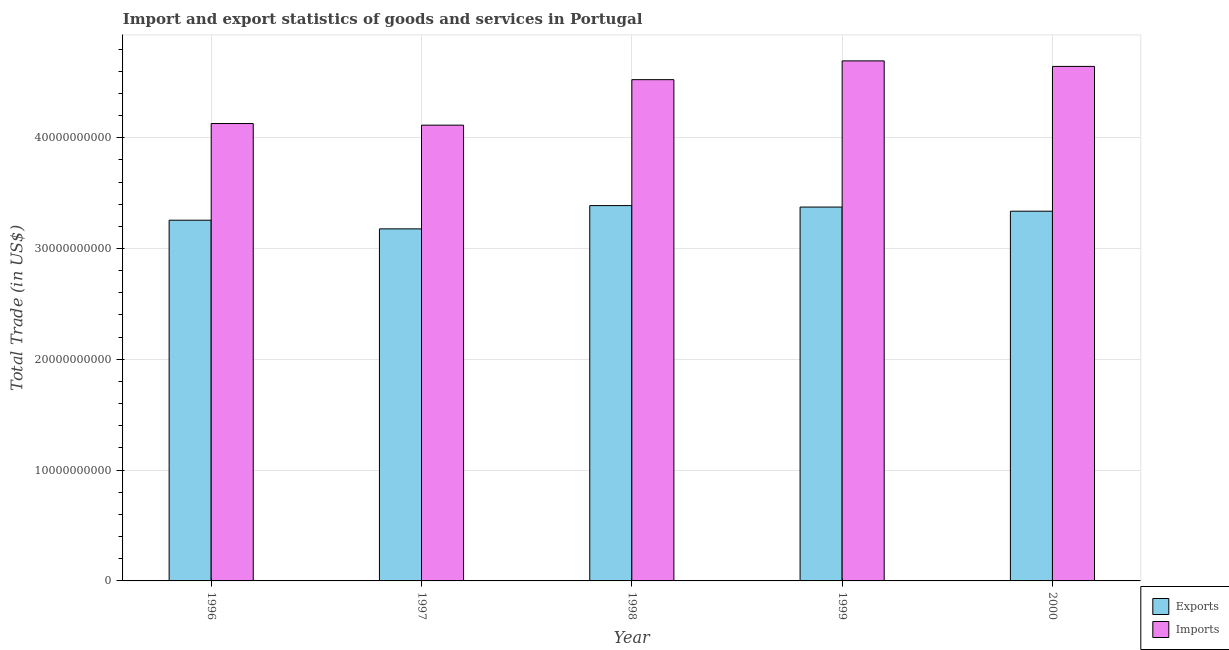How many different coloured bars are there?
Make the answer very short. 2. How many groups of bars are there?
Keep it short and to the point. 5. Are the number of bars on each tick of the X-axis equal?
Your answer should be very brief. Yes. How many bars are there on the 4th tick from the left?
Your answer should be compact. 2. How many bars are there on the 4th tick from the right?
Your answer should be compact. 2. In how many cases, is the number of bars for a given year not equal to the number of legend labels?
Your answer should be very brief. 0. What is the imports of goods and services in 1999?
Make the answer very short. 4.69e+1. Across all years, what is the maximum export of goods and services?
Provide a short and direct response. 3.39e+1. Across all years, what is the minimum imports of goods and services?
Offer a terse response. 4.11e+1. In which year was the export of goods and services maximum?
Ensure brevity in your answer.  1998. What is the total export of goods and services in the graph?
Your answer should be very brief. 1.65e+11. What is the difference between the export of goods and services in 1998 and that in 1999?
Give a very brief answer. 1.32e+08. What is the difference between the export of goods and services in 1998 and the imports of goods and services in 1999?
Provide a short and direct response. 1.32e+08. What is the average export of goods and services per year?
Provide a succinct answer. 3.31e+1. In the year 1998, what is the difference between the export of goods and services and imports of goods and services?
Your answer should be compact. 0. What is the ratio of the imports of goods and services in 1996 to that in 1999?
Provide a succinct answer. 0.88. Is the export of goods and services in 1998 less than that in 1999?
Provide a succinct answer. No. Is the difference between the imports of goods and services in 1996 and 2000 greater than the difference between the export of goods and services in 1996 and 2000?
Keep it short and to the point. No. What is the difference between the highest and the second highest export of goods and services?
Give a very brief answer. 1.32e+08. What is the difference between the highest and the lowest imports of goods and services?
Make the answer very short. 5.80e+09. What does the 1st bar from the left in 1997 represents?
Offer a terse response. Exports. What does the 1st bar from the right in 1998 represents?
Your answer should be compact. Imports. Are all the bars in the graph horizontal?
Make the answer very short. No. What is the difference between two consecutive major ticks on the Y-axis?
Your response must be concise. 1.00e+1. Are the values on the major ticks of Y-axis written in scientific E-notation?
Make the answer very short. No. Does the graph contain any zero values?
Offer a terse response. No. Where does the legend appear in the graph?
Make the answer very short. Bottom right. How many legend labels are there?
Your response must be concise. 2. What is the title of the graph?
Make the answer very short. Import and export statistics of goods and services in Portugal. What is the label or title of the Y-axis?
Give a very brief answer. Total Trade (in US$). What is the Total Trade (in US$) of Exports in 1996?
Your response must be concise. 3.26e+1. What is the Total Trade (in US$) in Imports in 1996?
Ensure brevity in your answer.  4.13e+1. What is the Total Trade (in US$) in Exports in 1997?
Provide a succinct answer. 3.18e+1. What is the Total Trade (in US$) in Imports in 1997?
Your answer should be very brief. 4.11e+1. What is the Total Trade (in US$) in Exports in 1998?
Keep it short and to the point. 3.39e+1. What is the Total Trade (in US$) of Imports in 1998?
Provide a short and direct response. 4.52e+1. What is the Total Trade (in US$) of Exports in 1999?
Provide a short and direct response. 3.37e+1. What is the Total Trade (in US$) of Imports in 1999?
Keep it short and to the point. 4.69e+1. What is the Total Trade (in US$) in Exports in 2000?
Your response must be concise. 3.34e+1. What is the Total Trade (in US$) of Imports in 2000?
Offer a terse response. 4.64e+1. Across all years, what is the maximum Total Trade (in US$) in Exports?
Provide a short and direct response. 3.39e+1. Across all years, what is the maximum Total Trade (in US$) in Imports?
Ensure brevity in your answer.  4.69e+1. Across all years, what is the minimum Total Trade (in US$) in Exports?
Your answer should be compact. 3.18e+1. Across all years, what is the minimum Total Trade (in US$) in Imports?
Your response must be concise. 4.11e+1. What is the total Total Trade (in US$) of Exports in the graph?
Offer a very short reply. 1.65e+11. What is the total Total Trade (in US$) in Imports in the graph?
Your answer should be compact. 2.21e+11. What is the difference between the Total Trade (in US$) in Exports in 1996 and that in 1997?
Provide a short and direct response. 7.82e+08. What is the difference between the Total Trade (in US$) of Imports in 1996 and that in 1997?
Your answer should be compact. 1.47e+08. What is the difference between the Total Trade (in US$) in Exports in 1996 and that in 1998?
Your answer should be compact. -1.32e+09. What is the difference between the Total Trade (in US$) of Imports in 1996 and that in 1998?
Offer a terse response. -3.96e+09. What is the difference between the Total Trade (in US$) of Exports in 1996 and that in 1999?
Provide a succinct answer. -1.19e+09. What is the difference between the Total Trade (in US$) in Imports in 1996 and that in 1999?
Offer a very short reply. -5.66e+09. What is the difference between the Total Trade (in US$) of Exports in 1996 and that in 2000?
Keep it short and to the point. -8.12e+08. What is the difference between the Total Trade (in US$) in Imports in 1996 and that in 2000?
Provide a short and direct response. -5.16e+09. What is the difference between the Total Trade (in US$) of Exports in 1997 and that in 1998?
Make the answer very short. -2.10e+09. What is the difference between the Total Trade (in US$) in Imports in 1997 and that in 1998?
Keep it short and to the point. -4.11e+09. What is the difference between the Total Trade (in US$) in Exports in 1997 and that in 1999?
Give a very brief answer. -1.97e+09. What is the difference between the Total Trade (in US$) in Imports in 1997 and that in 1999?
Provide a succinct answer. -5.80e+09. What is the difference between the Total Trade (in US$) in Exports in 1997 and that in 2000?
Provide a succinct answer. -1.59e+09. What is the difference between the Total Trade (in US$) in Imports in 1997 and that in 2000?
Provide a short and direct response. -5.30e+09. What is the difference between the Total Trade (in US$) in Exports in 1998 and that in 1999?
Provide a succinct answer. 1.32e+08. What is the difference between the Total Trade (in US$) in Imports in 1998 and that in 1999?
Offer a terse response. -1.69e+09. What is the difference between the Total Trade (in US$) in Exports in 1998 and that in 2000?
Give a very brief answer. 5.08e+08. What is the difference between the Total Trade (in US$) of Imports in 1998 and that in 2000?
Provide a short and direct response. -1.20e+09. What is the difference between the Total Trade (in US$) in Exports in 1999 and that in 2000?
Provide a succinct answer. 3.76e+08. What is the difference between the Total Trade (in US$) in Imports in 1999 and that in 2000?
Make the answer very short. 4.99e+08. What is the difference between the Total Trade (in US$) of Exports in 1996 and the Total Trade (in US$) of Imports in 1997?
Your answer should be very brief. -8.58e+09. What is the difference between the Total Trade (in US$) in Exports in 1996 and the Total Trade (in US$) in Imports in 1998?
Make the answer very short. -1.27e+1. What is the difference between the Total Trade (in US$) of Exports in 1996 and the Total Trade (in US$) of Imports in 1999?
Make the answer very short. -1.44e+1. What is the difference between the Total Trade (in US$) of Exports in 1996 and the Total Trade (in US$) of Imports in 2000?
Give a very brief answer. -1.39e+1. What is the difference between the Total Trade (in US$) of Exports in 1997 and the Total Trade (in US$) of Imports in 1998?
Ensure brevity in your answer.  -1.35e+1. What is the difference between the Total Trade (in US$) of Exports in 1997 and the Total Trade (in US$) of Imports in 1999?
Your answer should be compact. -1.52e+1. What is the difference between the Total Trade (in US$) of Exports in 1997 and the Total Trade (in US$) of Imports in 2000?
Ensure brevity in your answer.  -1.47e+1. What is the difference between the Total Trade (in US$) of Exports in 1998 and the Total Trade (in US$) of Imports in 1999?
Make the answer very short. -1.31e+1. What is the difference between the Total Trade (in US$) of Exports in 1998 and the Total Trade (in US$) of Imports in 2000?
Provide a succinct answer. -1.26e+1. What is the difference between the Total Trade (in US$) of Exports in 1999 and the Total Trade (in US$) of Imports in 2000?
Give a very brief answer. -1.27e+1. What is the average Total Trade (in US$) of Exports per year?
Make the answer very short. 3.31e+1. What is the average Total Trade (in US$) in Imports per year?
Offer a terse response. 4.42e+1. In the year 1996, what is the difference between the Total Trade (in US$) in Exports and Total Trade (in US$) in Imports?
Keep it short and to the point. -8.72e+09. In the year 1997, what is the difference between the Total Trade (in US$) of Exports and Total Trade (in US$) of Imports?
Keep it short and to the point. -9.36e+09. In the year 1998, what is the difference between the Total Trade (in US$) in Exports and Total Trade (in US$) in Imports?
Your answer should be compact. -1.14e+1. In the year 1999, what is the difference between the Total Trade (in US$) of Exports and Total Trade (in US$) of Imports?
Your answer should be very brief. -1.32e+1. In the year 2000, what is the difference between the Total Trade (in US$) in Exports and Total Trade (in US$) in Imports?
Offer a terse response. -1.31e+1. What is the ratio of the Total Trade (in US$) in Exports in 1996 to that in 1997?
Your response must be concise. 1.02. What is the ratio of the Total Trade (in US$) of Imports in 1996 to that in 1997?
Provide a succinct answer. 1. What is the ratio of the Total Trade (in US$) in Imports in 1996 to that in 1998?
Ensure brevity in your answer.  0.91. What is the ratio of the Total Trade (in US$) of Exports in 1996 to that in 1999?
Give a very brief answer. 0.96. What is the ratio of the Total Trade (in US$) in Imports in 1996 to that in 1999?
Provide a short and direct response. 0.88. What is the ratio of the Total Trade (in US$) of Exports in 1996 to that in 2000?
Keep it short and to the point. 0.98. What is the ratio of the Total Trade (in US$) in Imports in 1996 to that in 2000?
Give a very brief answer. 0.89. What is the ratio of the Total Trade (in US$) of Exports in 1997 to that in 1998?
Your answer should be very brief. 0.94. What is the ratio of the Total Trade (in US$) of Imports in 1997 to that in 1998?
Offer a very short reply. 0.91. What is the ratio of the Total Trade (in US$) in Exports in 1997 to that in 1999?
Offer a very short reply. 0.94. What is the ratio of the Total Trade (in US$) in Imports in 1997 to that in 1999?
Your response must be concise. 0.88. What is the ratio of the Total Trade (in US$) in Exports in 1997 to that in 2000?
Provide a short and direct response. 0.95. What is the ratio of the Total Trade (in US$) of Imports in 1997 to that in 2000?
Offer a very short reply. 0.89. What is the ratio of the Total Trade (in US$) in Exports in 1998 to that in 1999?
Provide a short and direct response. 1. What is the ratio of the Total Trade (in US$) in Imports in 1998 to that in 1999?
Ensure brevity in your answer.  0.96. What is the ratio of the Total Trade (in US$) in Exports in 1998 to that in 2000?
Provide a succinct answer. 1.02. What is the ratio of the Total Trade (in US$) of Imports in 1998 to that in 2000?
Your answer should be compact. 0.97. What is the ratio of the Total Trade (in US$) in Exports in 1999 to that in 2000?
Your answer should be compact. 1.01. What is the ratio of the Total Trade (in US$) of Imports in 1999 to that in 2000?
Keep it short and to the point. 1.01. What is the difference between the highest and the second highest Total Trade (in US$) in Exports?
Give a very brief answer. 1.32e+08. What is the difference between the highest and the second highest Total Trade (in US$) in Imports?
Provide a short and direct response. 4.99e+08. What is the difference between the highest and the lowest Total Trade (in US$) in Exports?
Provide a succinct answer. 2.10e+09. What is the difference between the highest and the lowest Total Trade (in US$) of Imports?
Your answer should be compact. 5.80e+09. 